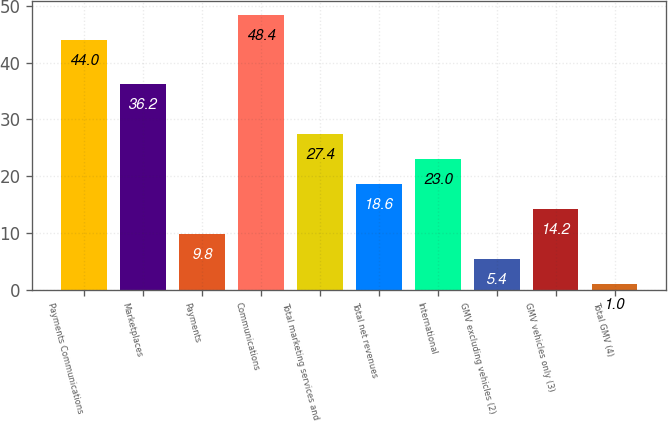Convert chart. <chart><loc_0><loc_0><loc_500><loc_500><bar_chart><fcel>Payments Communications<fcel>Marketplaces<fcel>Payments<fcel>Communications<fcel>Total marketing services and<fcel>Total net revenues<fcel>International<fcel>GMV excluding vehicles (2)<fcel>GMV vehicles only (3)<fcel>Total GMV (4)<nl><fcel>44<fcel>36.2<fcel>9.8<fcel>48.4<fcel>27.4<fcel>18.6<fcel>23<fcel>5.4<fcel>14.2<fcel>1<nl></chart> 